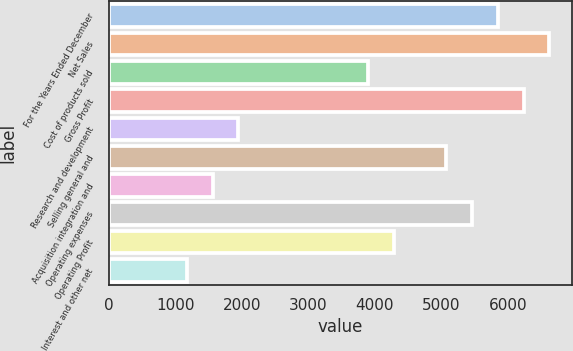<chart> <loc_0><loc_0><loc_500><loc_500><bar_chart><fcel>For the Years Ended December<fcel>Net Sales<fcel>Cost of products sold<fcel>Gross Profit<fcel>Research and development<fcel>Selling general and<fcel>Acquisition integration and<fcel>Operating expenses<fcel>Operating Profit<fcel>Interest and other net<nl><fcel>5846<fcel>6625.4<fcel>3897.5<fcel>6235.7<fcel>1949<fcel>5066.6<fcel>1559.3<fcel>5456.3<fcel>4287.2<fcel>1169.6<nl></chart> 